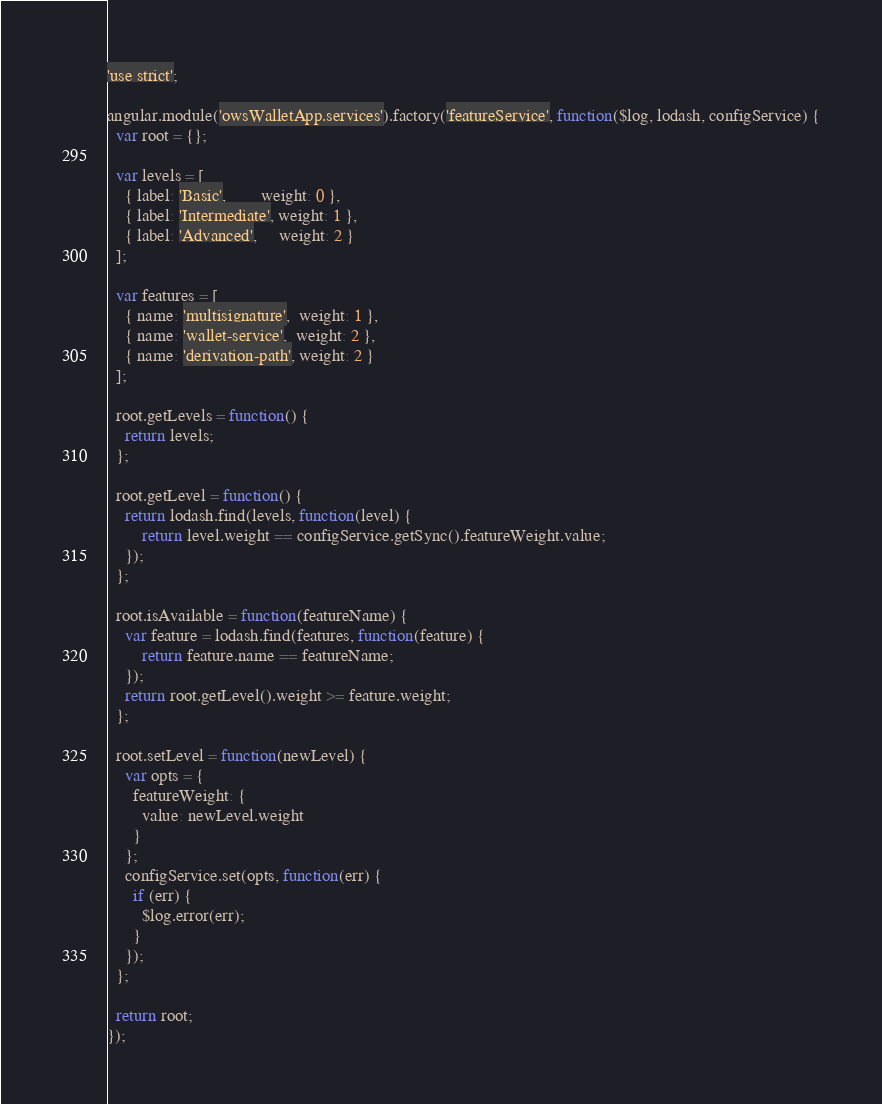Convert code to text. <code><loc_0><loc_0><loc_500><loc_500><_JavaScript_>'use strict';

angular.module('owsWalletApp.services').factory('featureService', function($log, lodash, configService) {
  var root = {};

  var levels = [
  	{ label: 'Basic',        weight: 0 },
  	{ label: 'Intermediate', weight: 1 },
  	{ label: 'Advanced',     weight: 2 }
  ];

  var features = [
  	{ name: 'multisignature',  weight: 1 },
  	{ name: 'wallet-service',  weight: 2 },
  	{ name: 'derivation-path', weight: 2 }
  ];

  root.getLevels = function() {
  	return levels;
  };

  root.getLevel = function() {
  	return lodash.find(levels, function(level) {
  		return level.weight == configService.getSync().featureWeight.value;
  	});
  };

  root.isAvailable = function(featureName) {
  	var feature = lodash.find(features, function(feature) {
  		return feature.name == featureName;
  	});
  	return root.getLevel().weight >= feature.weight;
  };

  root.setLevel = function(newLevel) {
    var opts = {
      featureWeight: {
        value: newLevel.weight
      }
    };
    configService.set(opts, function(err) {
      if (err) {
        $log.error(err);
      }
    });
  };

  return root;
});
</code> 